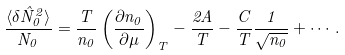<formula> <loc_0><loc_0><loc_500><loc_500>\frac { \langle \delta \hat { N } _ { 0 } ^ { 2 } \rangle } { N _ { 0 } } = \frac { T } { n _ { 0 } } \left ( \frac { \partial n _ { 0 } } { \partial \mu } \right ) _ { T } - \frac { 2 A } { T } - \frac { C } { T } \frac { 1 } { \sqrt { n _ { 0 } } } + \cdots .</formula> 